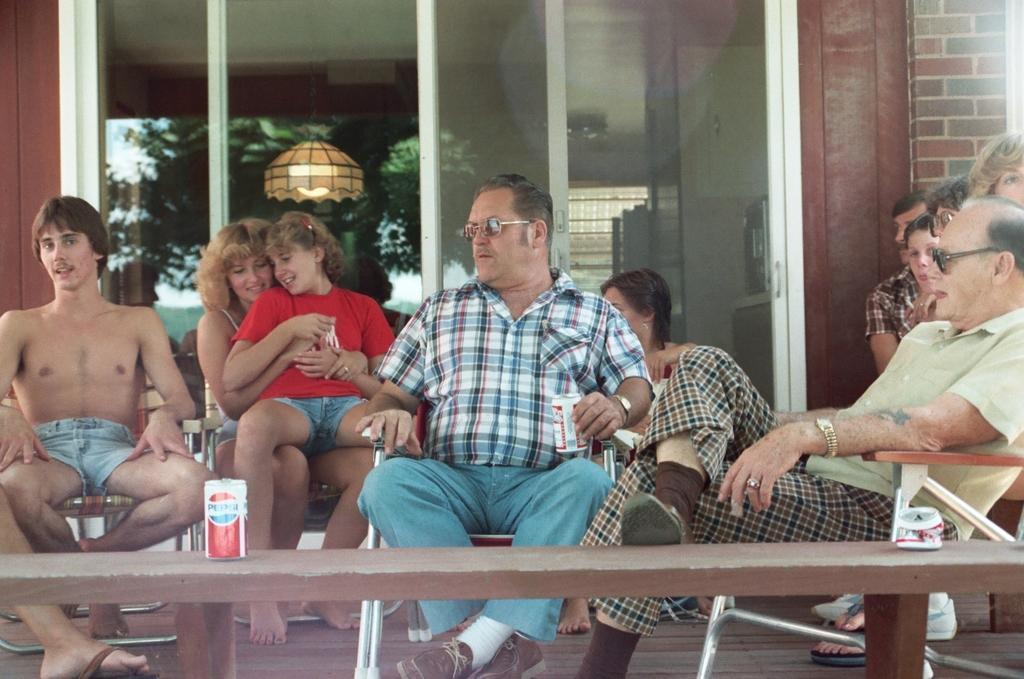In one or two sentences, can you explain what this image depicts? This picture shows a group of people seated on the chairs and we see a house 